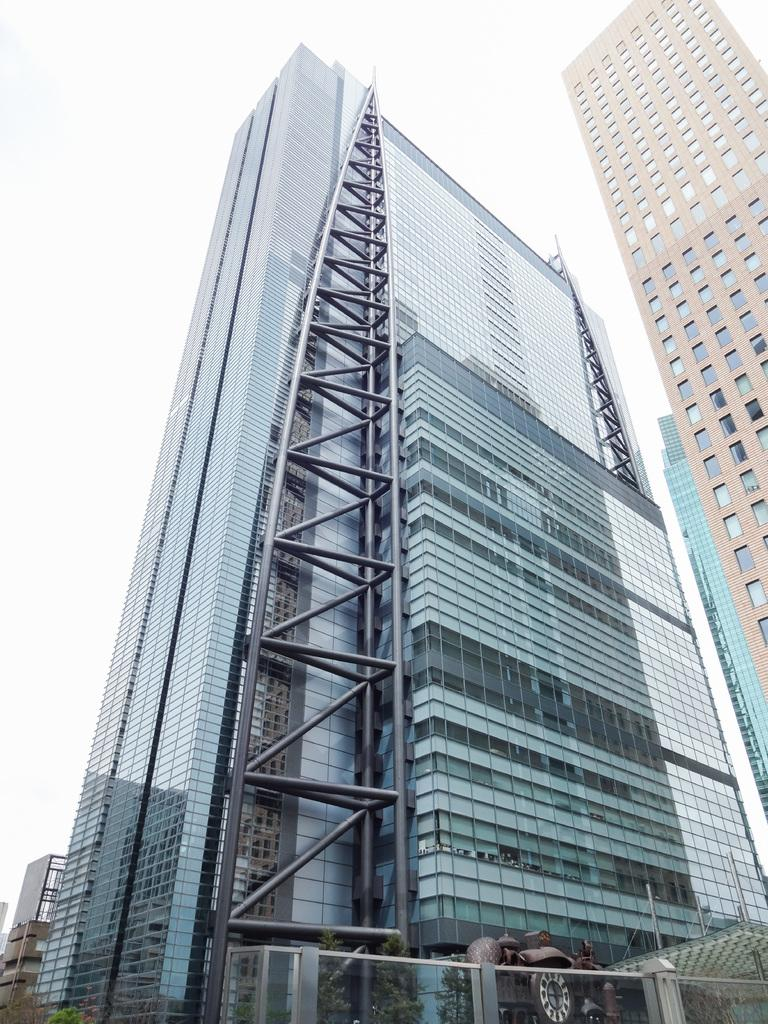What type of structures can be seen in the image? There are buildings in the image. What is located at the bottom of the image? There is a fence at the bottom of the image. What is behind the fence? There is a statue behind the fence. What is located behind the statue? There are trees behind the statue. What can be seen at the top of the image? The sky is visible at the top of the image. Can you tell me how many snails are crawling on the statue in the image? There are no snails present on the statue in the image. What type of bag is hanging on the fence in the image? There is no bag hanging on the fence in the image. 